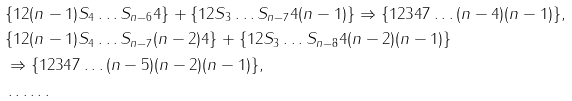<formula> <loc_0><loc_0><loc_500><loc_500>& \{ 1 2 ( n - 1 ) S _ { 4 } \dots S _ { n - 6 } 4 \} + \{ 1 2 S _ { 3 } \dots S _ { n - 7 } 4 ( n - 1 ) \} \Rightarrow \{ 1 2 3 4 7 \dots ( n - 4 ) ( n - 1 ) \} , \\ & \{ 1 2 ( n - 1 ) S _ { 4 } \dots S _ { n - 7 } ( n - 2 ) 4 \} + \{ 1 2 S _ { 3 } \dots S _ { n - 8 } 4 ( n - 2 ) ( n - 1 ) \} \\ & \Rightarrow \{ 1 2 3 4 7 \dots ( n - 5 ) ( n - 2 ) ( n - 1 ) \} , \\ & \dots \dots</formula> 